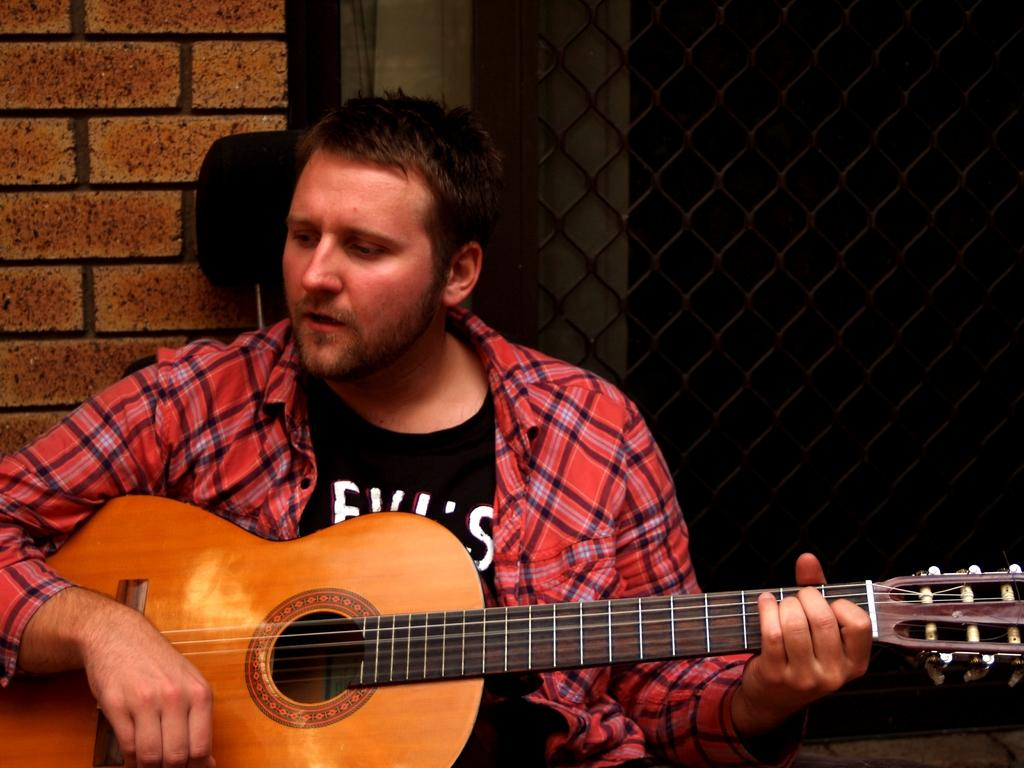Who is the main subject in the image? There is a person in the image. What is the person doing in the image? The person is sitting on a chair and playing a guitar. What can be seen in the background of the image? There is a wall visible in the background of the image. How does the person in the image express disgust while playing the guitar? There is no indication of the person expressing disgust in the image; they are simply playing the guitar. 